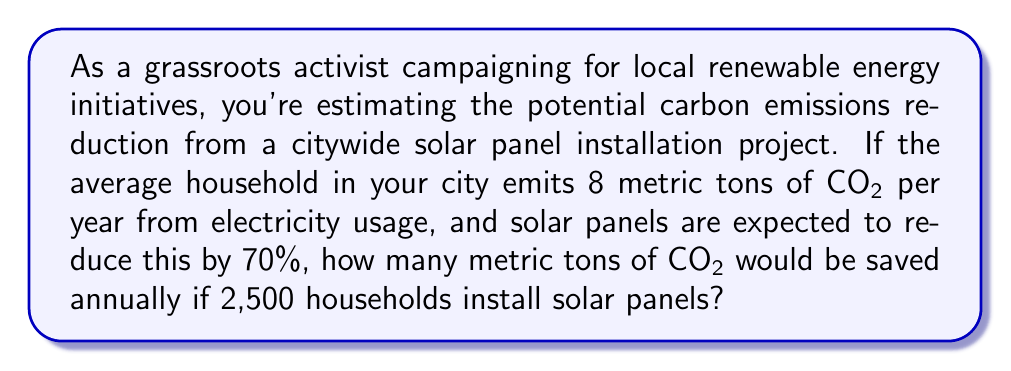Teach me how to tackle this problem. To solve this problem, we'll follow these steps:

1. Calculate the CO2 emissions reduced per household:
   - Annual CO2 emissions per household = 8 metric tons
   - Reduction percentage = 70% = 0.70
   - CO2 reduced per household = $8 \times 0.70 = 5.6$ metric tons

2. Calculate the total CO2 emissions reduced for all households:
   - Number of households installing solar panels = 2,500
   - Total CO2 reduced = CO2 reduced per household $\times$ Number of households
   - Total CO2 reduced = $5.6 \times 2,500 = 14,000$ metric tons

Therefore, the total annual CO2 emissions reduction would be 14,000 metric tons.

This calculation can be represented as a single equation:

$$ \text{Total CO2 reduced} = \text{Annual emissions per household} \times \text{Reduction percentage} \times \text{Number of households} $$

$$ \text{Total CO2 reduced} = 8 \times 0.70 \times 2,500 = 14,000 \text{ metric tons} $$
Answer: 14,000 metric tons of CO2 would be saved annually. 